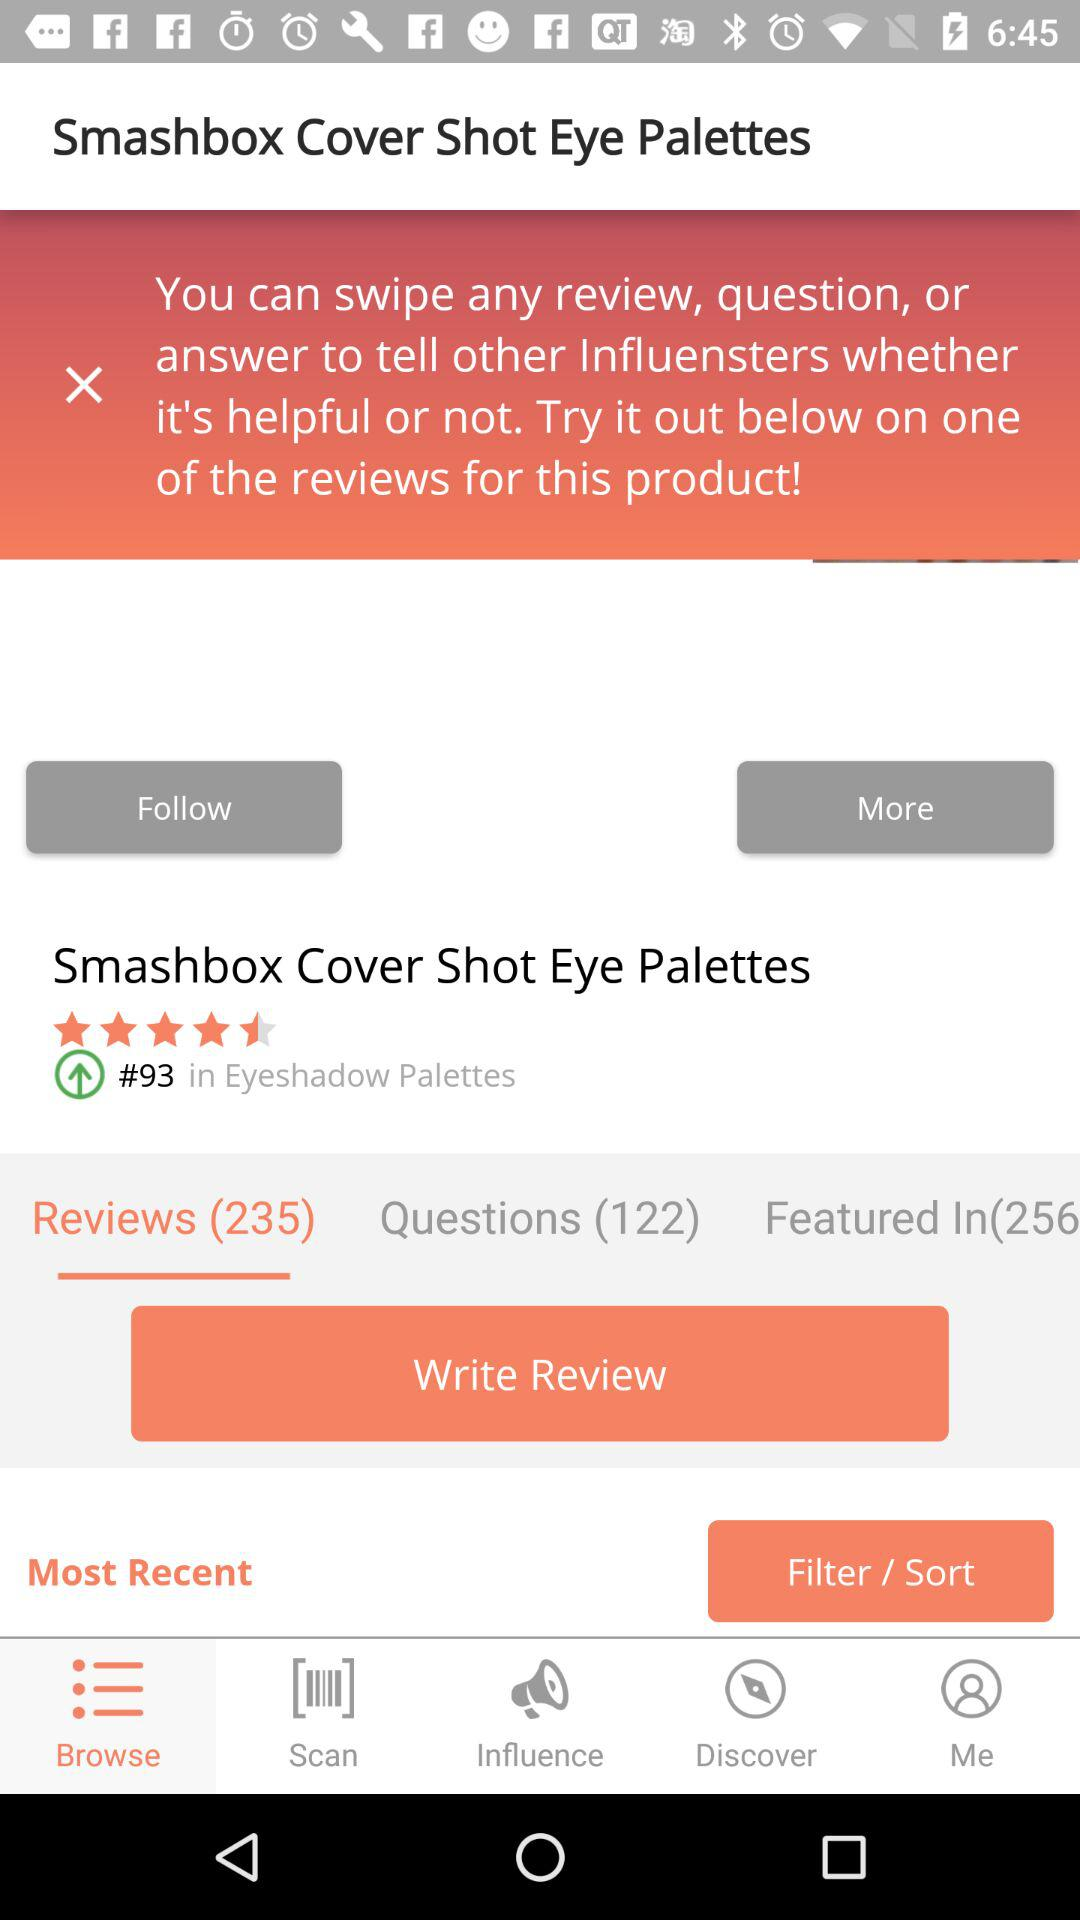How many more reviews than questions are there for this product?
Answer the question using a single word or phrase. 113 